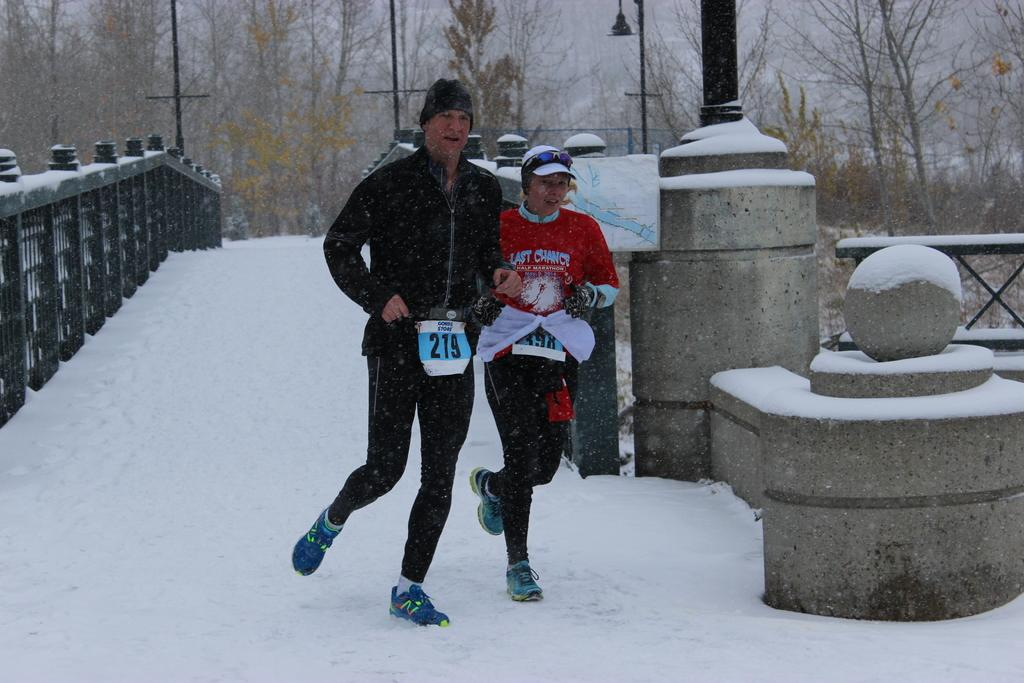<image>
Describe the image concisely. A man, wearing number 219, runs alongside a woman in the snow. 